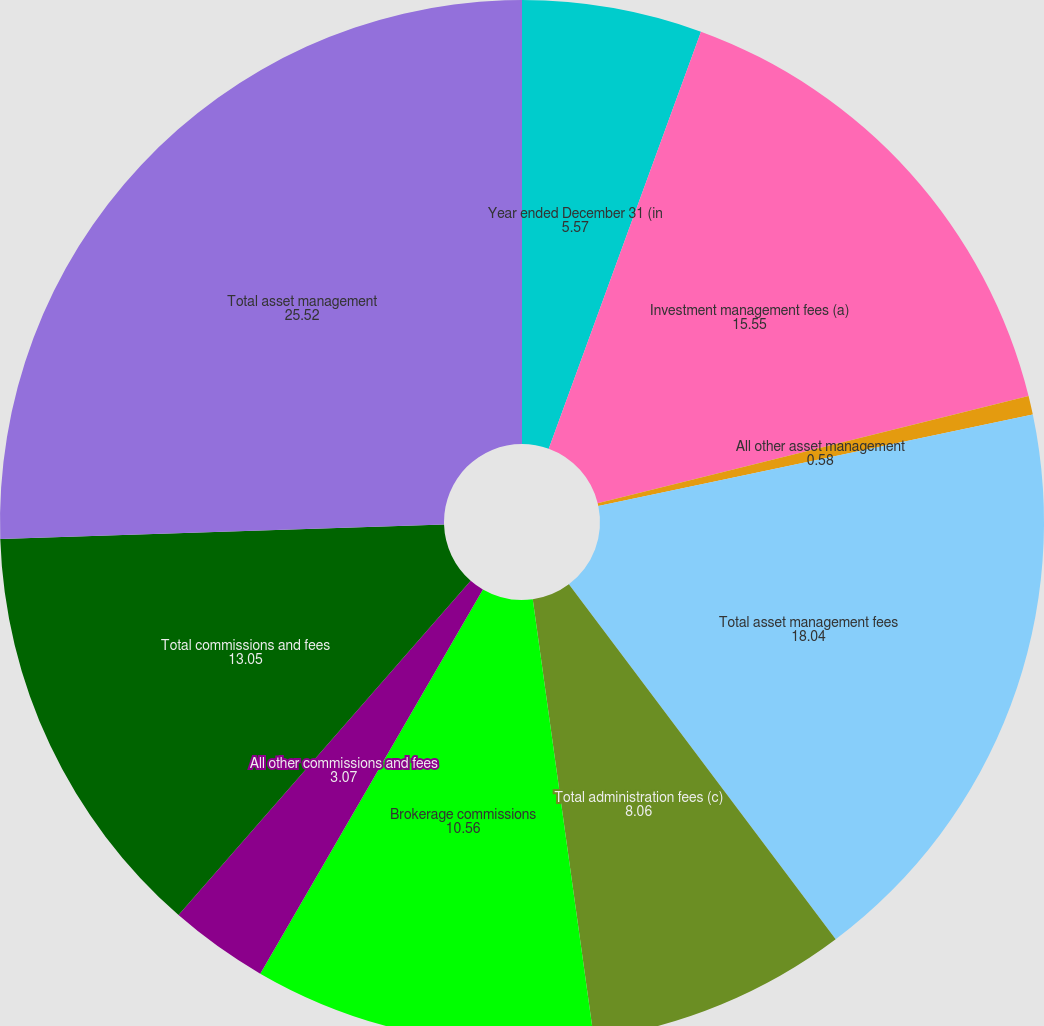Convert chart. <chart><loc_0><loc_0><loc_500><loc_500><pie_chart><fcel>Year ended December 31 (in<fcel>Investment management fees (a)<fcel>All other asset management<fcel>Total asset management fees<fcel>Total administration fees (c)<fcel>Brokerage commissions<fcel>All other commissions and fees<fcel>Total commissions and fees<fcel>Total asset management<nl><fcel>5.57%<fcel>15.55%<fcel>0.58%<fcel>18.04%<fcel>8.06%<fcel>10.56%<fcel>3.07%<fcel>13.05%<fcel>25.52%<nl></chart> 